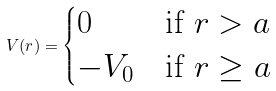Convert formula to latex. <formula><loc_0><loc_0><loc_500><loc_500>V ( r ) = \begin{cases} 0 & \text {if $r>a$} \\ - V _ { 0 } & \text {if $r\geq a $} \end{cases}</formula> 